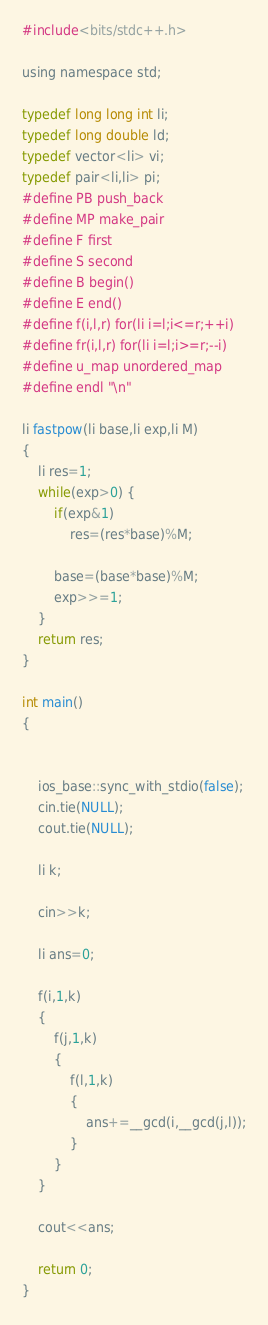Convert code to text. <code><loc_0><loc_0><loc_500><loc_500><_C_>#include<bits/stdc++.h>

using namespace std;

typedef long long int li;
typedef long double ld;
typedef vector<li> vi;
typedef pair<li,li> pi;
#define PB push_back
#define MP make_pair
#define F first
#define S second
#define B begin()
#define E end()
#define f(i,l,r) for(li i=l;i<=r;++i)
#define fr(i,l,r) for(li i=l;i>=r;--i)
#define u_map unordered_map
#define endl "\n"

li fastpow(li base,li exp,li M) 
{
    li res=1;
    while(exp>0) {
        if(exp&1)
            res=(res*base)%M;

        base=(base*base)%M;
        exp>>=1;
    }
    return res;
}

int main()
{    
    

    ios_base::sync_with_stdio(false);
    cin.tie(NULL);
    cout.tie(NULL);

    li k;

    cin>>k;

    li ans=0;

    f(i,1,k)
    {
        f(j,1,k)
        {
            f(l,1,k)
            {
                ans+=__gcd(i,__gcd(j,l));
            }
        }
    }

    cout<<ans;

    return 0;
}</code> 